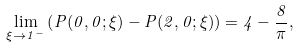<formula> <loc_0><loc_0><loc_500><loc_500>\lim _ { \xi \to 1 ^ { - } } \left ( P ( 0 , 0 ; \xi ) - P ( 2 , 0 ; \xi ) \right ) = 4 - \frac { 8 } { \pi } ,</formula> 